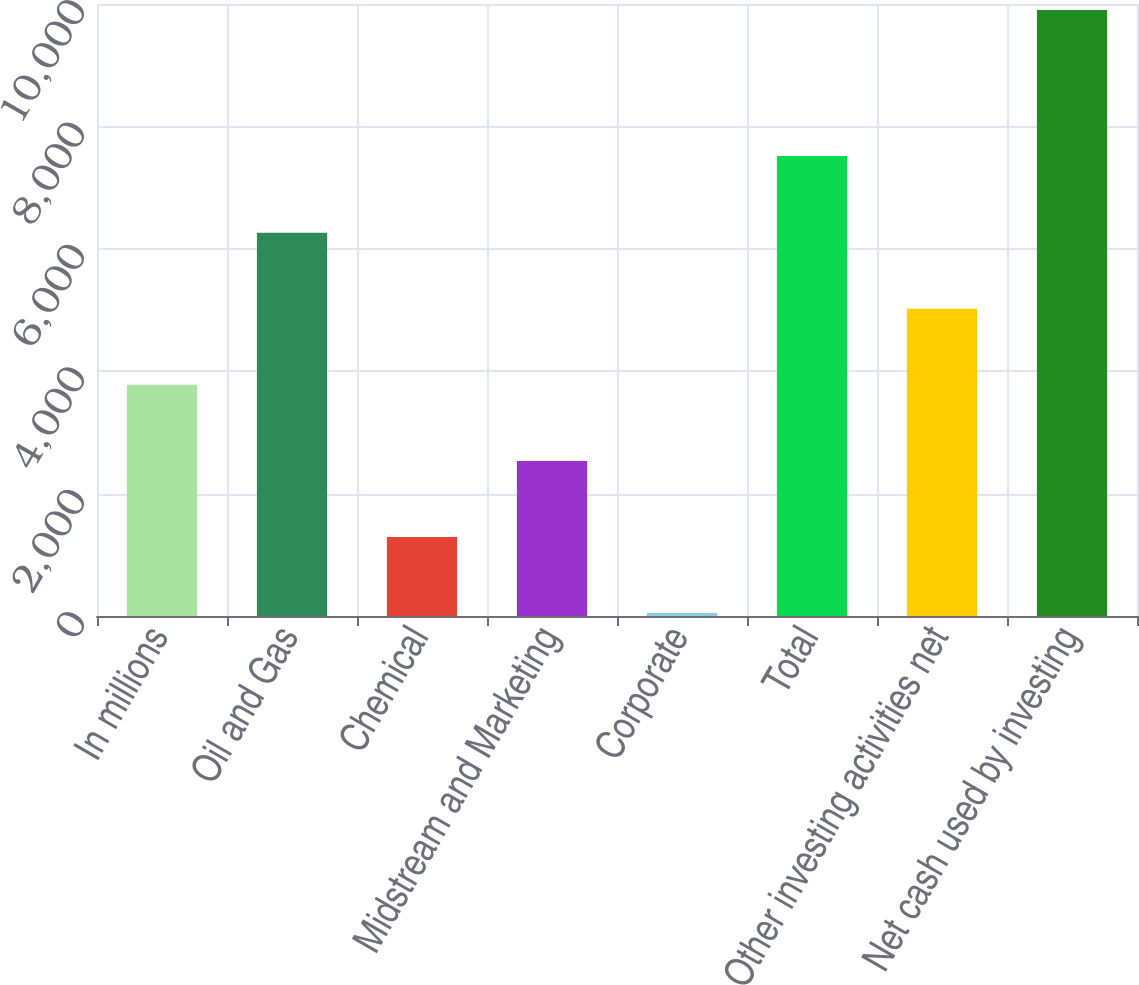Convert chart to OTSL. <chart><loc_0><loc_0><loc_500><loc_500><bar_chart><fcel>In millions<fcel>Oil and Gas<fcel>Chemical<fcel>Midstream and Marketing<fcel>Corporate<fcel>Total<fcel>Other investing activities net<fcel>Net cash used by investing<nl><fcel>3776.9<fcel>6261.5<fcel>1292.3<fcel>2534.6<fcel>50<fcel>7518<fcel>5019.2<fcel>9903<nl></chart> 